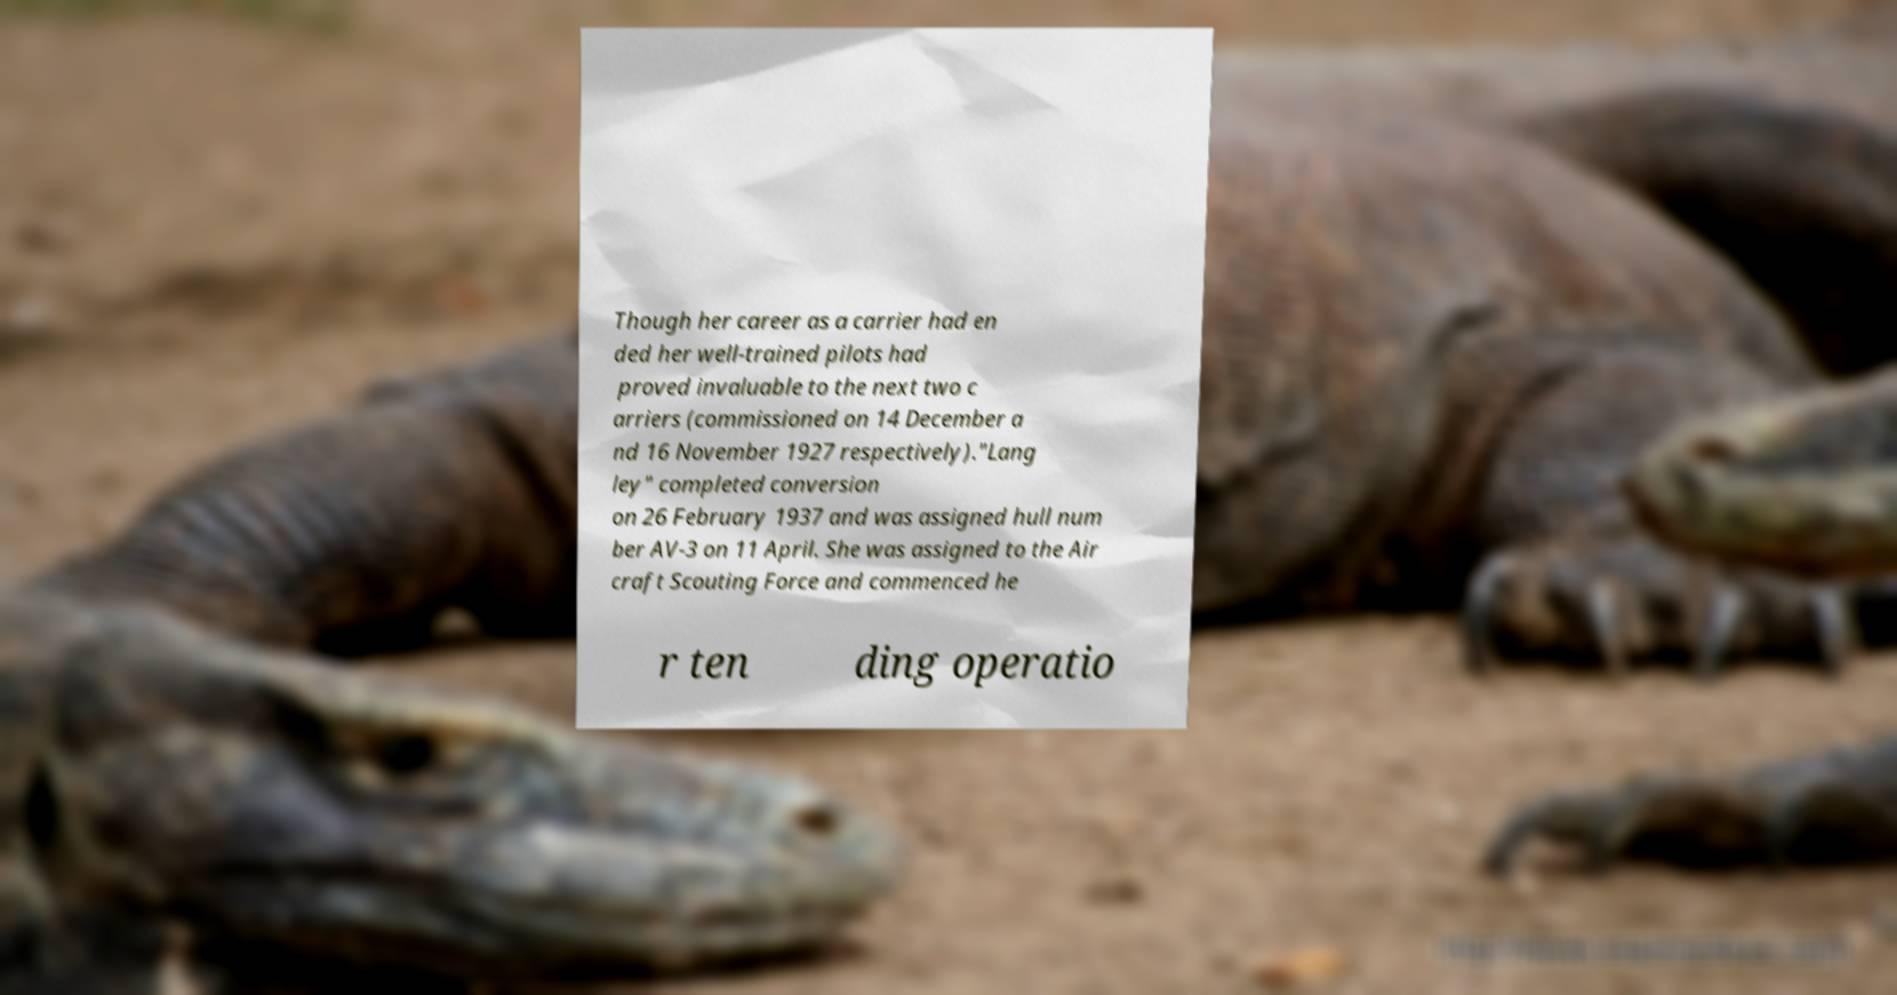There's text embedded in this image that I need extracted. Can you transcribe it verbatim? Though her career as a carrier had en ded her well-trained pilots had proved invaluable to the next two c arriers (commissioned on 14 December a nd 16 November 1927 respectively)."Lang ley" completed conversion on 26 February 1937 and was assigned hull num ber AV-3 on 11 April. She was assigned to the Air craft Scouting Force and commenced he r ten ding operatio 